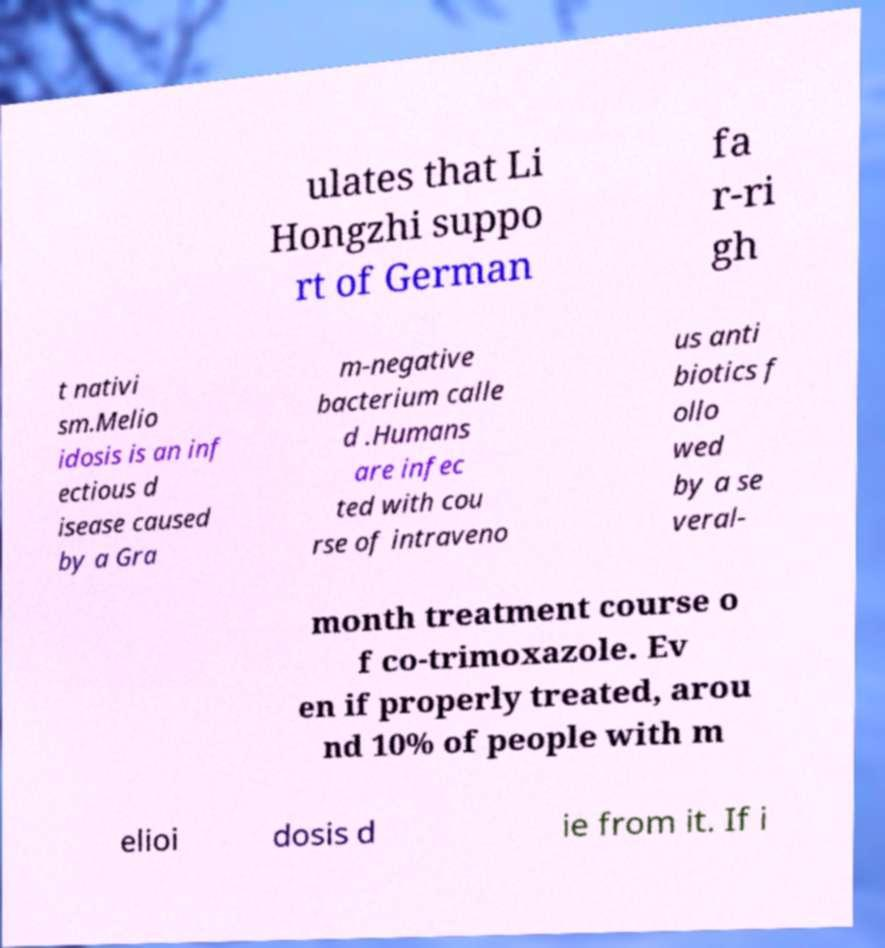Can you accurately transcribe the text from the provided image for me? ulates that Li Hongzhi suppo rt of German fa r-ri gh t nativi sm.Melio idosis is an inf ectious d isease caused by a Gra m-negative bacterium calle d .Humans are infec ted with cou rse of intraveno us anti biotics f ollo wed by a se veral- month treatment course o f co-trimoxazole. Ev en if properly treated, arou nd 10% of people with m elioi dosis d ie from it. If i 